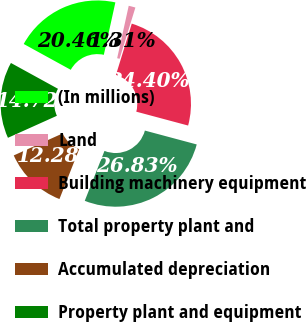Convert chart. <chart><loc_0><loc_0><loc_500><loc_500><pie_chart><fcel>(In millions)<fcel>Land<fcel>Building machinery equipment<fcel>Total property plant and<fcel>Accumulated depreciation<fcel>Property plant and equipment<nl><fcel>20.46%<fcel>1.31%<fcel>24.4%<fcel>26.83%<fcel>12.28%<fcel>14.72%<nl></chart> 